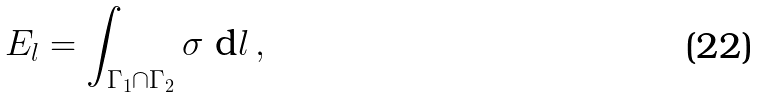<formula> <loc_0><loc_0><loc_500><loc_500>E _ { l } = \int _ { \Gamma _ { 1 } \cap \Gamma _ { 2 } } \sigma \ \text {d} l \, ,</formula> 